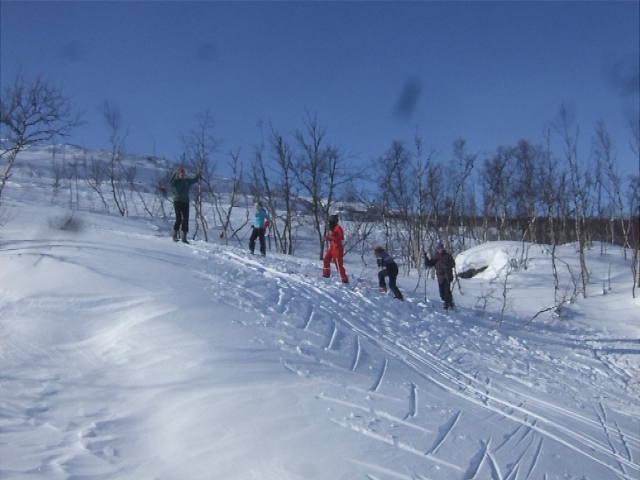How many people are wearing red?
Give a very brief answer. 1. How many people are in the picture?
Give a very brief answer. 5. How many sheep are there?
Give a very brief answer. 0. 